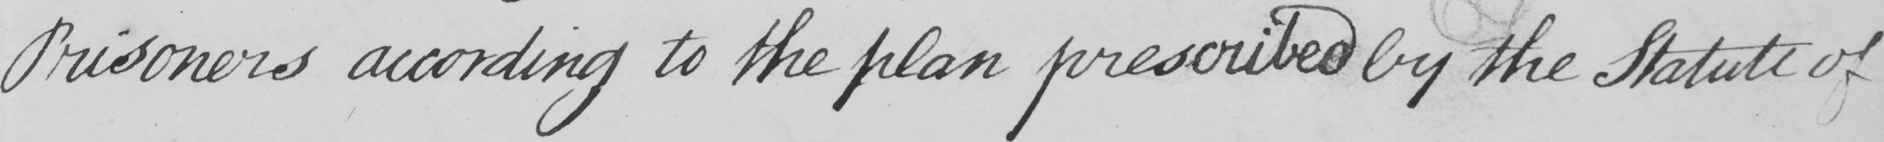What is written in this line of handwriting? Prisoners according to the plan prescribed by the Statute of 